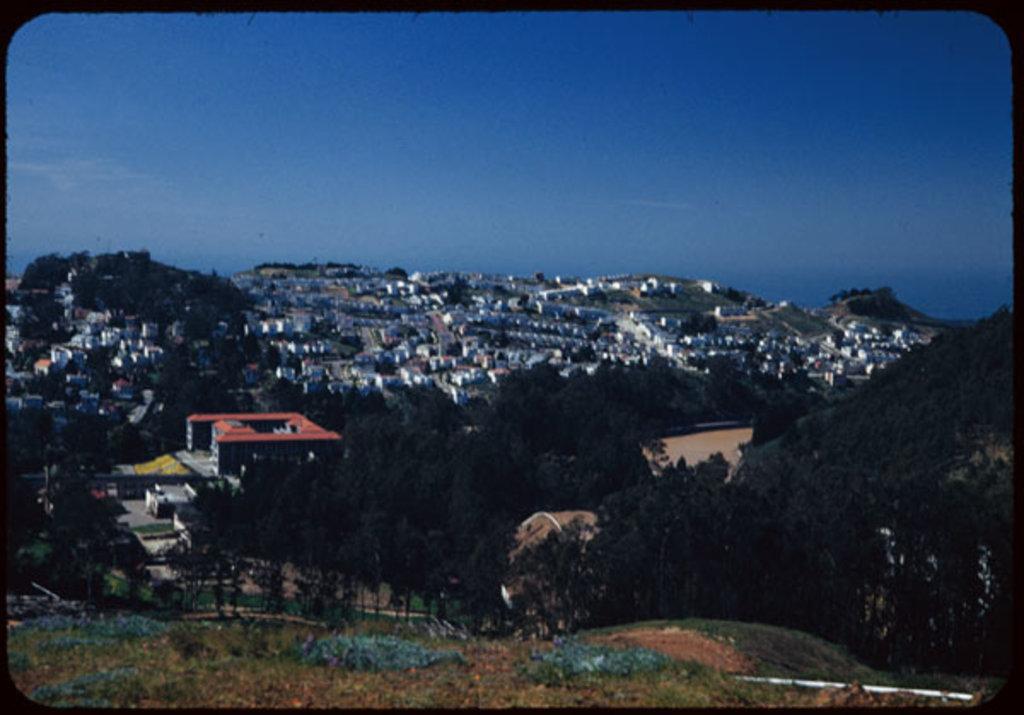In one or two sentences, can you explain what this image depicts? In this image I can see the grass. In the background, I can see the trees, buildings and the sky. 